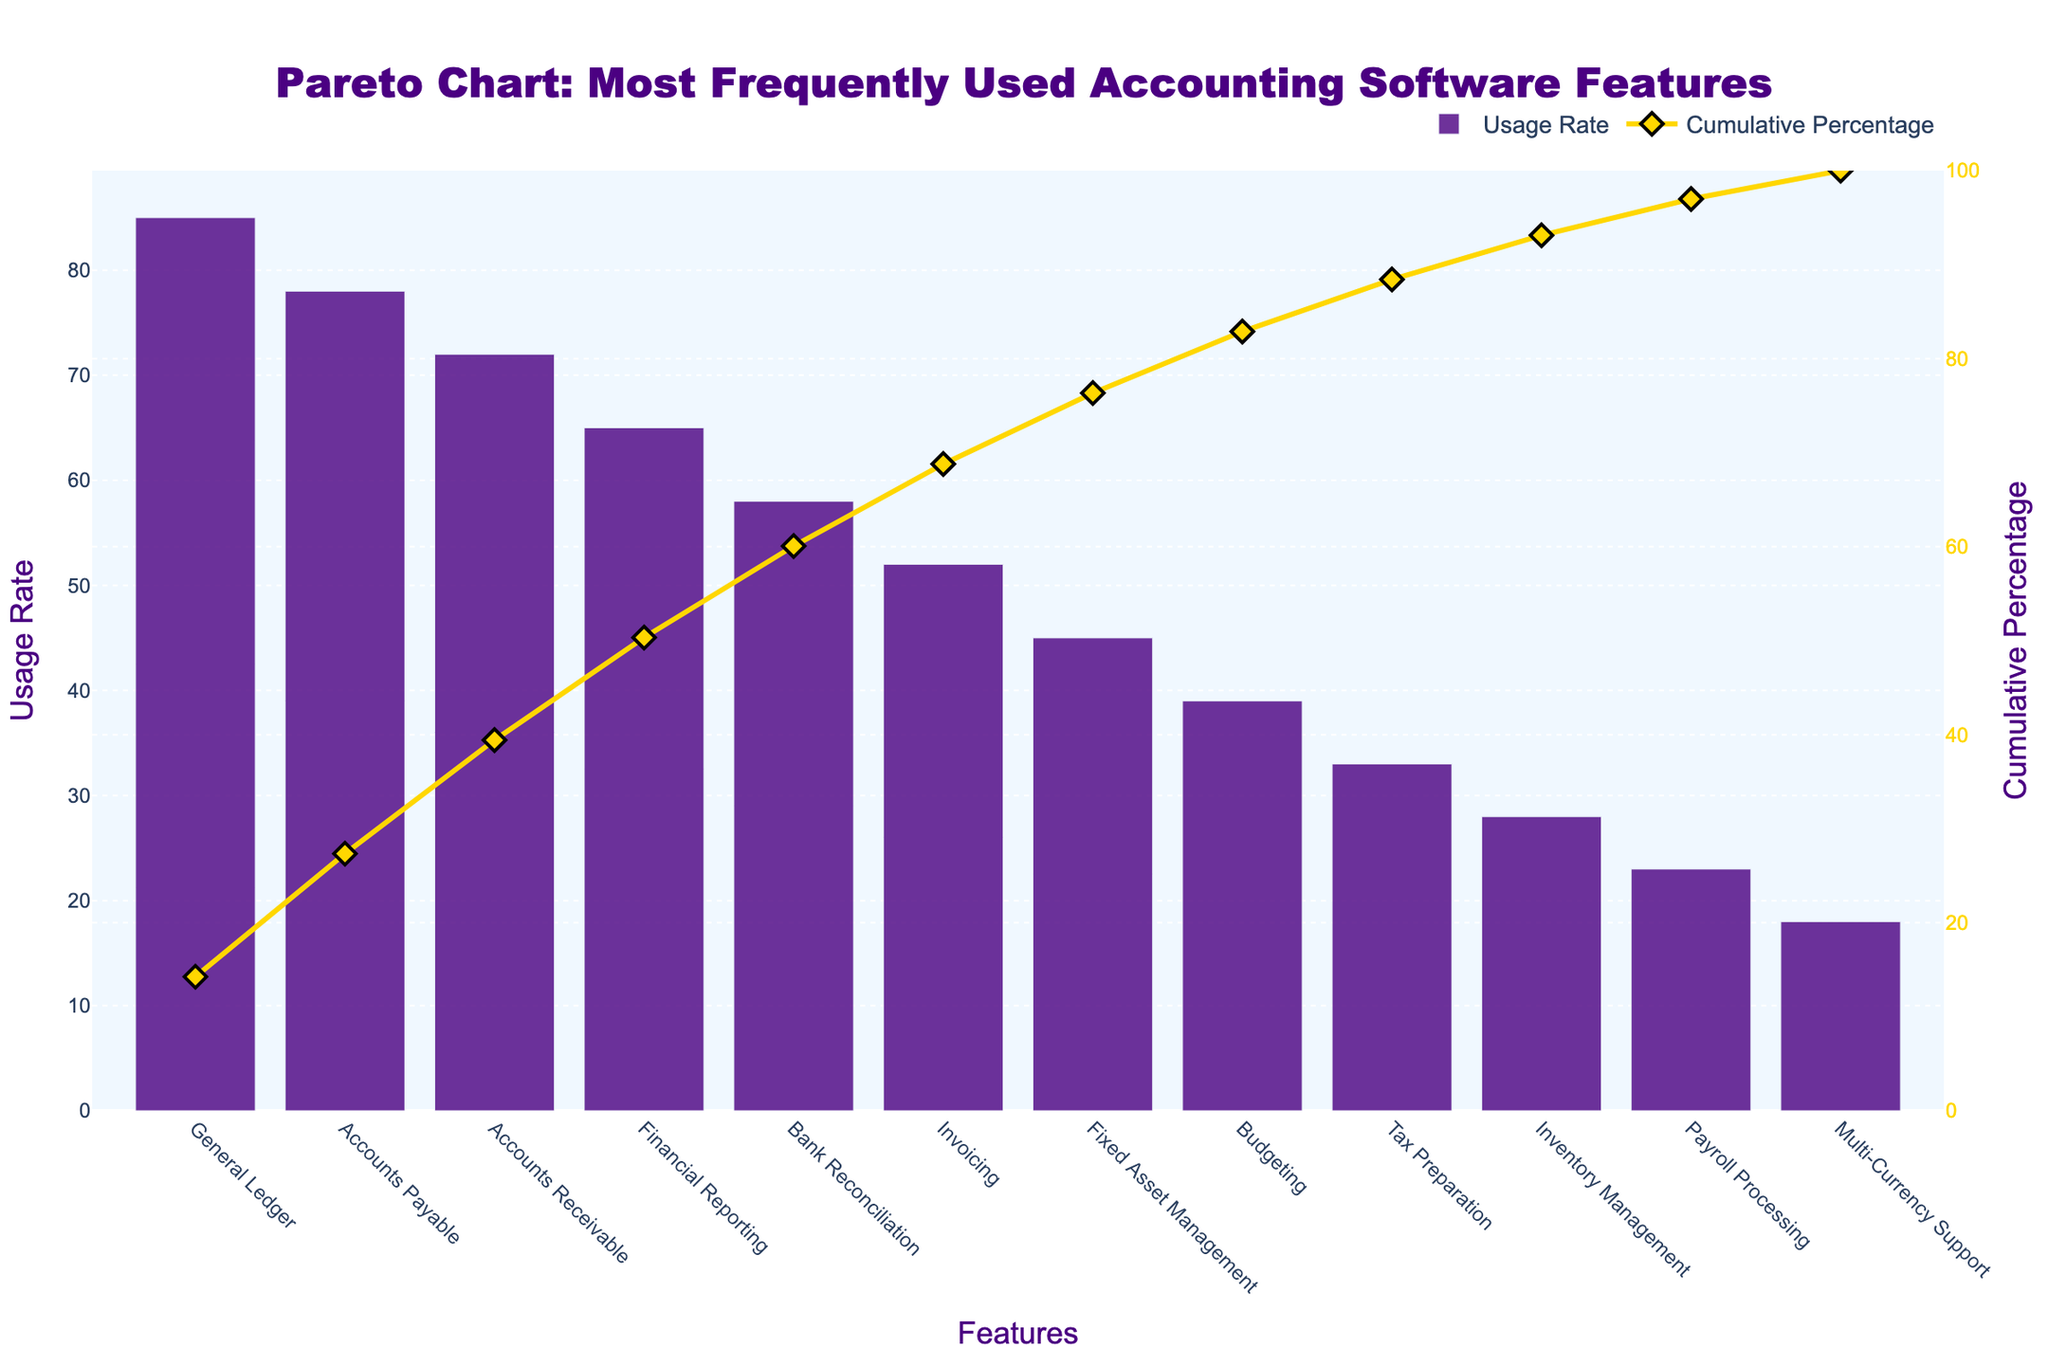what is the most frequently used accounting software feature? Look at the bar with the highest usage rate in the figure, which is the first bar on the left.
Answer: General Ledger What is the title of the Pareto chart? The title is usually displayed at the top of the figure.
Answer: Pareto Chart: Most Frequently Used Accounting Software Features What are the y-axis labels on the left side of the chart and what do they represent? The left y-axis labels can be found alongside the vertical axis and they represent the "Usage Rate" of the features.
Answer: Usage Rate By how much does the Usage Rate of General Ledger exceed that of Payroll Processing? Identify the Usage Rates of General Ledger (85) and Payroll Processing (23), then subtract the latter from the former.
Answer: 62 Which feature has the lowest Usage Rate? Find the feature with the shortest bar height or smallest value on the x-axis.
Answer: Multi-Currency Support What is the cumulative percentage when the Payroll Processing feature is included? Locate the cumulative percentage line at the position aligned with Payroll Processing (23% into the sequence). The cumulative percentage is indicated by the value at that point on the right y-axis, which is indicated by the "Cumulative Percentage" value in the table that includes all previous features' usage rates summed up to Payroll Processing.
Answer: 98% Which features have a Usage Rate greater than 50%? Look for the bars where Usage Rate is greater than 50 on the y-axis. This includes General Ledger, Accounts Payable, Accounts Receivable, Financial Reporting, and Bank Reconciliation.
Answer: General Ledger, Accounts Payable, Accounts Receivable, Financial Reporting, Bank Reconciliation What is the cumulative percentage after adding Accounts Receivable? Find the cumulative percentage value corresponding to the total after the Accounts Receivable bar (which accounts for 72% used).
Answer: 75% What is the average (mean) Usage Rate of all features? Sum all the Usage Rate values (85 + 78 + 72 + 65 + 58 + 52 + 45 + 39 + 33 + 28 + 23 + 18) and divide by the number of features (12).
Answer: 49.42 How many features constitute at least 80% of the total Usage Rate? Check the cumulative percentage line and see how many features must be included to reach 80% of the cumulative total. General Ledger, Accounts Payable, Accounts Receivable, and Financial Reporting should be summed up to match at least 80%.
Answer: 4 